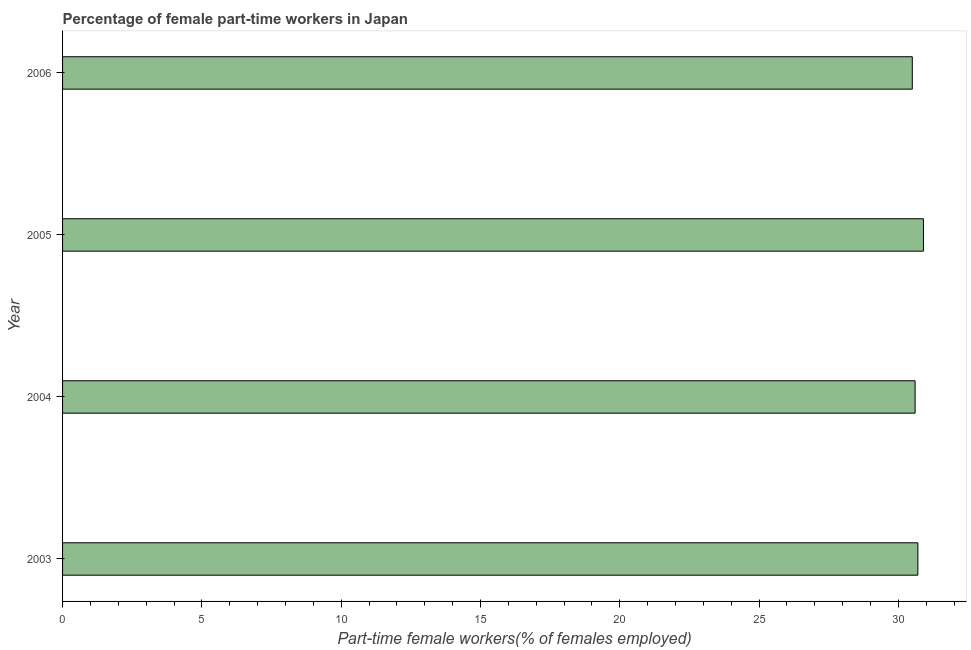Does the graph contain any zero values?
Give a very brief answer. No. Does the graph contain grids?
Ensure brevity in your answer.  No. What is the title of the graph?
Your answer should be very brief. Percentage of female part-time workers in Japan. What is the label or title of the X-axis?
Provide a succinct answer. Part-time female workers(% of females employed). What is the label or title of the Y-axis?
Your response must be concise. Year. What is the percentage of part-time female workers in 2003?
Offer a very short reply. 30.7. Across all years, what is the maximum percentage of part-time female workers?
Provide a succinct answer. 30.9. Across all years, what is the minimum percentage of part-time female workers?
Your answer should be compact. 30.5. What is the sum of the percentage of part-time female workers?
Provide a succinct answer. 122.7. What is the average percentage of part-time female workers per year?
Provide a short and direct response. 30.68. What is the median percentage of part-time female workers?
Your answer should be very brief. 30.65. In how many years, is the percentage of part-time female workers greater than 15 %?
Your response must be concise. 4. Is the percentage of part-time female workers in 2003 less than that in 2006?
Provide a short and direct response. No. Is the sum of the percentage of part-time female workers in 2003 and 2005 greater than the maximum percentage of part-time female workers across all years?
Offer a very short reply. Yes. What is the difference between the highest and the lowest percentage of part-time female workers?
Provide a succinct answer. 0.4. In how many years, is the percentage of part-time female workers greater than the average percentage of part-time female workers taken over all years?
Offer a very short reply. 2. Are the values on the major ticks of X-axis written in scientific E-notation?
Make the answer very short. No. What is the Part-time female workers(% of females employed) of 2003?
Offer a terse response. 30.7. What is the Part-time female workers(% of females employed) of 2004?
Provide a short and direct response. 30.6. What is the Part-time female workers(% of females employed) of 2005?
Ensure brevity in your answer.  30.9. What is the Part-time female workers(% of females employed) in 2006?
Keep it short and to the point. 30.5. What is the difference between the Part-time female workers(% of females employed) in 2003 and 2005?
Offer a terse response. -0.2. What is the ratio of the Part-time female workers(% of females employed) in 2003 to that in 2004?
Provide a short and direct response. 1. What is the ratio of the Part-time female workers(% of females employed) in 2003 to that in 2006?
Your answer should be compact. 1.01. What is the ratio of the Part-time female workers(% of females employed) in 2004 to that in 2005?
Make the answer very short. 0.99. What is the ratio of the Part-time female workers(% of females employed) in 2005 to that in 2006?
Your answer should be compact. 1.01. 